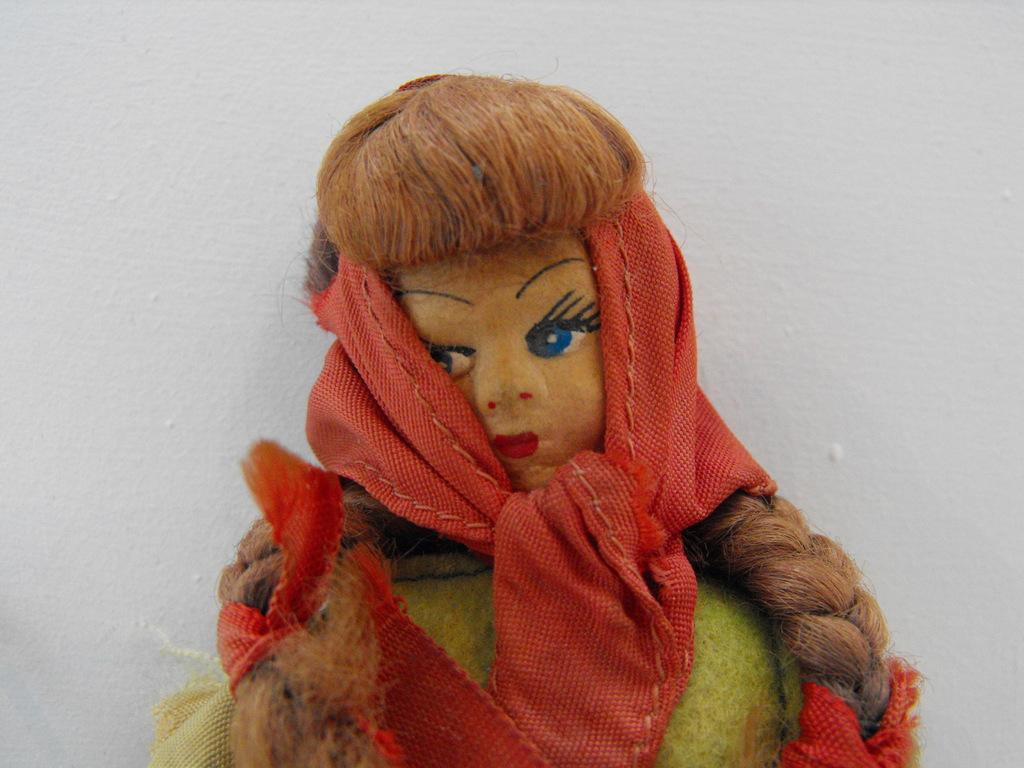What is the main subject of the image? There is a doll in the image. What can be seen in the background of the image? There is a wall in the background of the image. What type of material is visible in the image? There is a cloth visible in the image. What type of weather can be seen in the image? There is no indication of weather in the image, as it is focused on the doll and the wall in the background. 